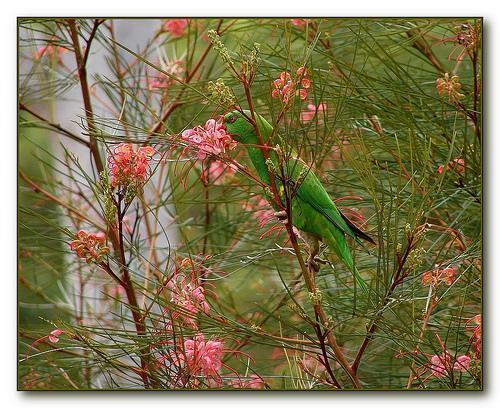How many birds are perched within the tree?
Give a very brief answer. 1. 